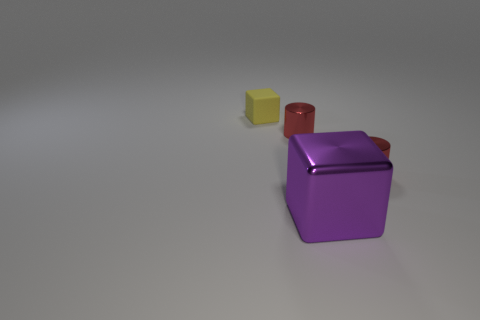Add 3 tiny gray matte blocks. How many objects exist? 7 Subtract all yellow cubes. How many cubes are left? 1 Subtract 1 blocks. How many blocks are left? 1 Add 2 large things. How many large things are left? 3 Add 1 things. How many things exist? 5 Subtract 0 blue spheres. How many objects are left? 4 Subtract all brown cubes. Subtract all brown cylinders. How many cubes are left? 2 Subtract all blue objects. Subtract all large purple metallic blocks. How many objects are left? 3 